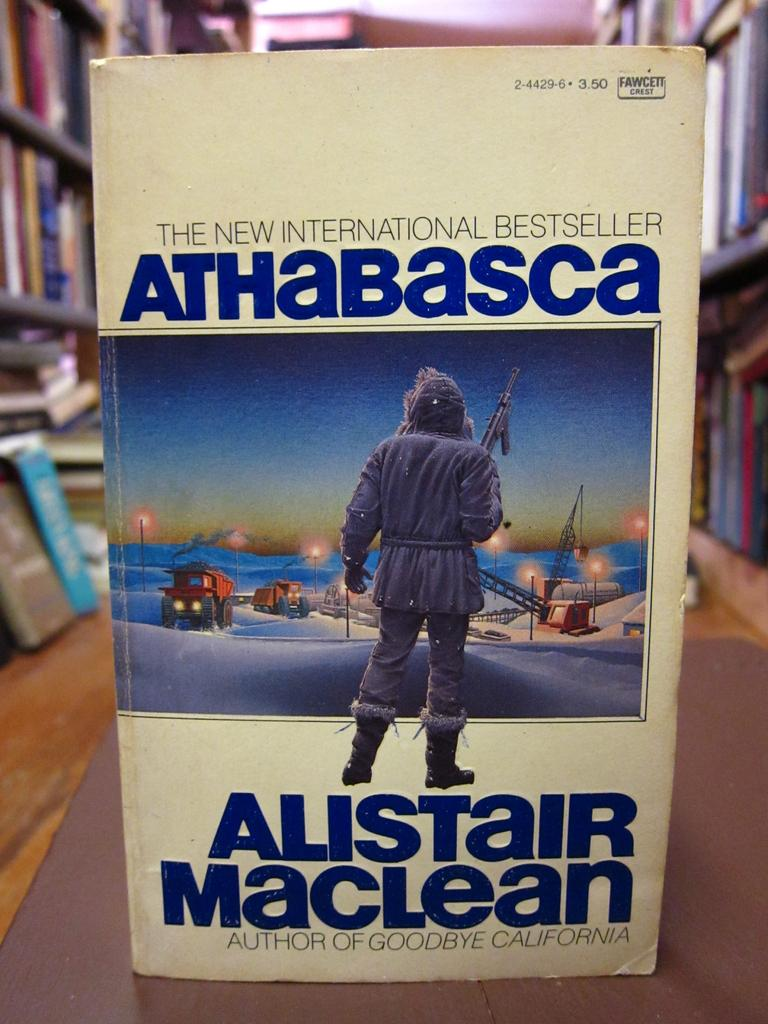<image>
Summarize the visual content of the image. A book called Athabasca is an international bestseller. 